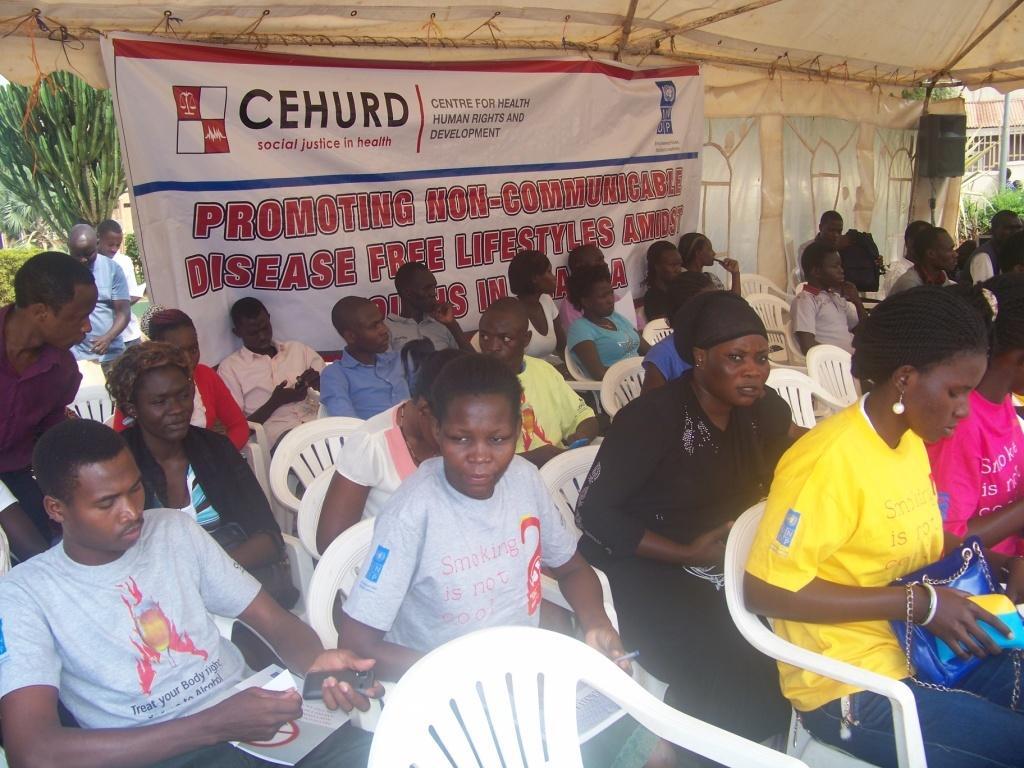In one or two sentences, can you explain what this image depicts? In this picture we can see some people are sitting on chairs, a man at the left bottom is holding a mobile phone, there is a banner in the middle, on the right side we can see a speaker, in the background there are plants and a tree, a woman on the right side is holding a bag. 